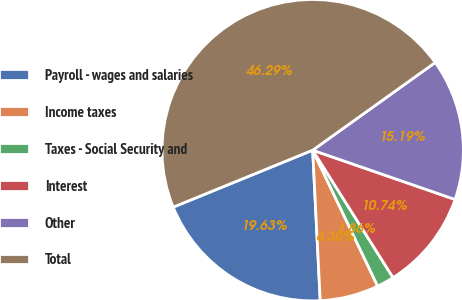Convert chart. <chart><loc_0><loc_0><loc_500><loc_500><pie_chart><fcel>Payroll - wages and salaries<fcel>Income taxes<fcel>Taxes - Social Security and<fcel>Interest<fcel>Other<fcel>Total<nl><fcel>19.63%<fcel>6.3%<fcel>1.86%<fcel>10.74%<fcel>15.19%<fcel>46.29%<nl></chart> 